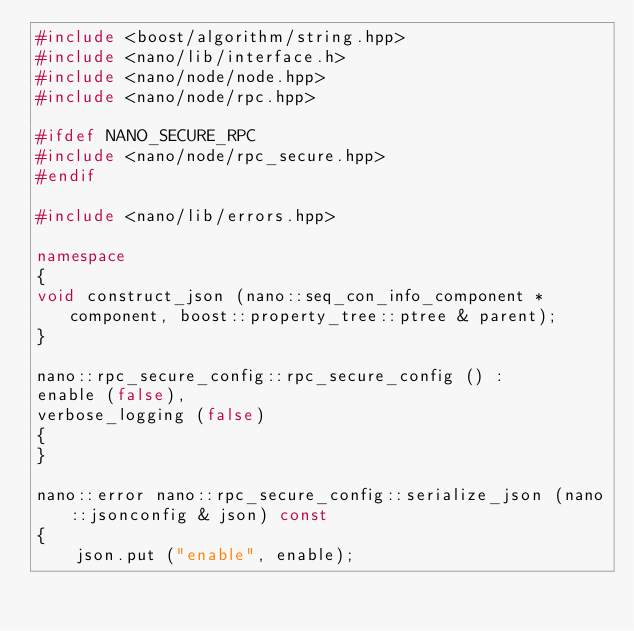Convert code to text. <code><loc_0><loc_0><loc_500><loc_500><_C++_>#include <boost/algorithm/string.hpp>
#include <nano/lib/interface.h>
#include <nano/node/node.hpp>
#include <nano/node/rpc.hpp>

#ifdef NANO_SECURE_RPC
#include <nano/node/rpc_secure.hpp>
#endif

#include <nano/lib/errors.hpp>

namespace
{
void construct_json (nano::seq_con_info_component * component, boost::property_tree::ptree & parent);
}

nano::rpc_secure_config::rpc_secure_config () :
enable (false),
verbose_logging (false)
{
}

nano::error nano::rpc_secure_config::serialize_json (nano::jsonconfig & json) const
{
	json.put ("enable", enable);</code> 